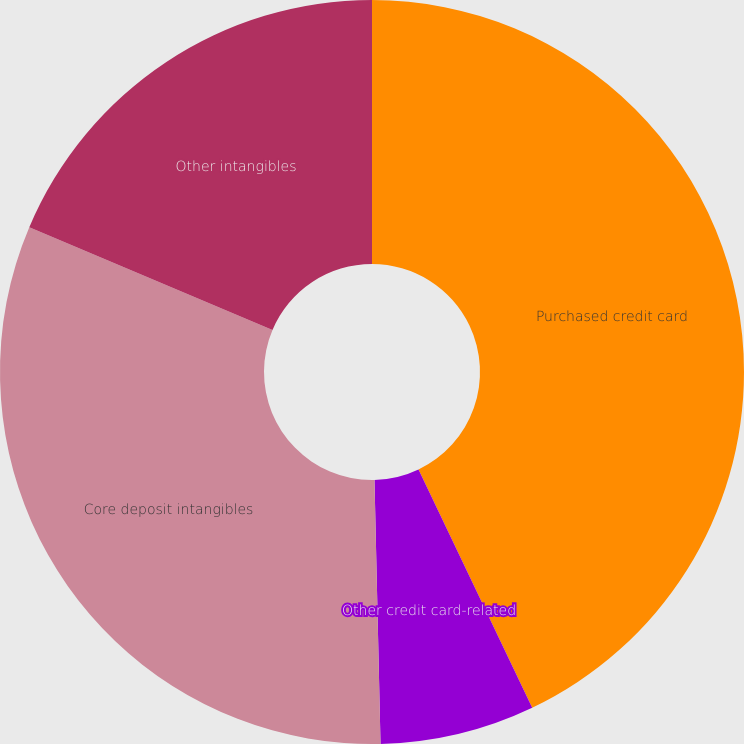<chart> <loc_0><loc_0><loc_500><loc_500><pie_chart><fcel>Purchased credit card<fcel>Other credit card-related<fcel>Core deposit intangibles<fcel>Other intangibles<nl><fcel>42.91%<fcel>6.72%<fcel>31.72%<fcel>18.64%<nl></chart> 